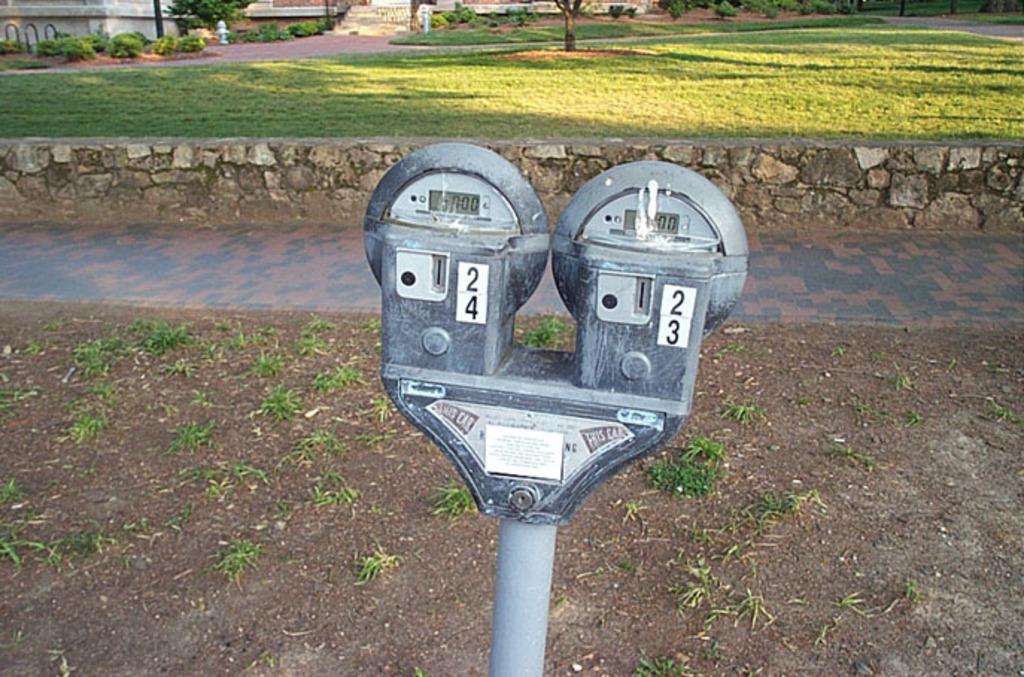What numbers are on these meters?
Provide a short and direct response. 24 and 23. 